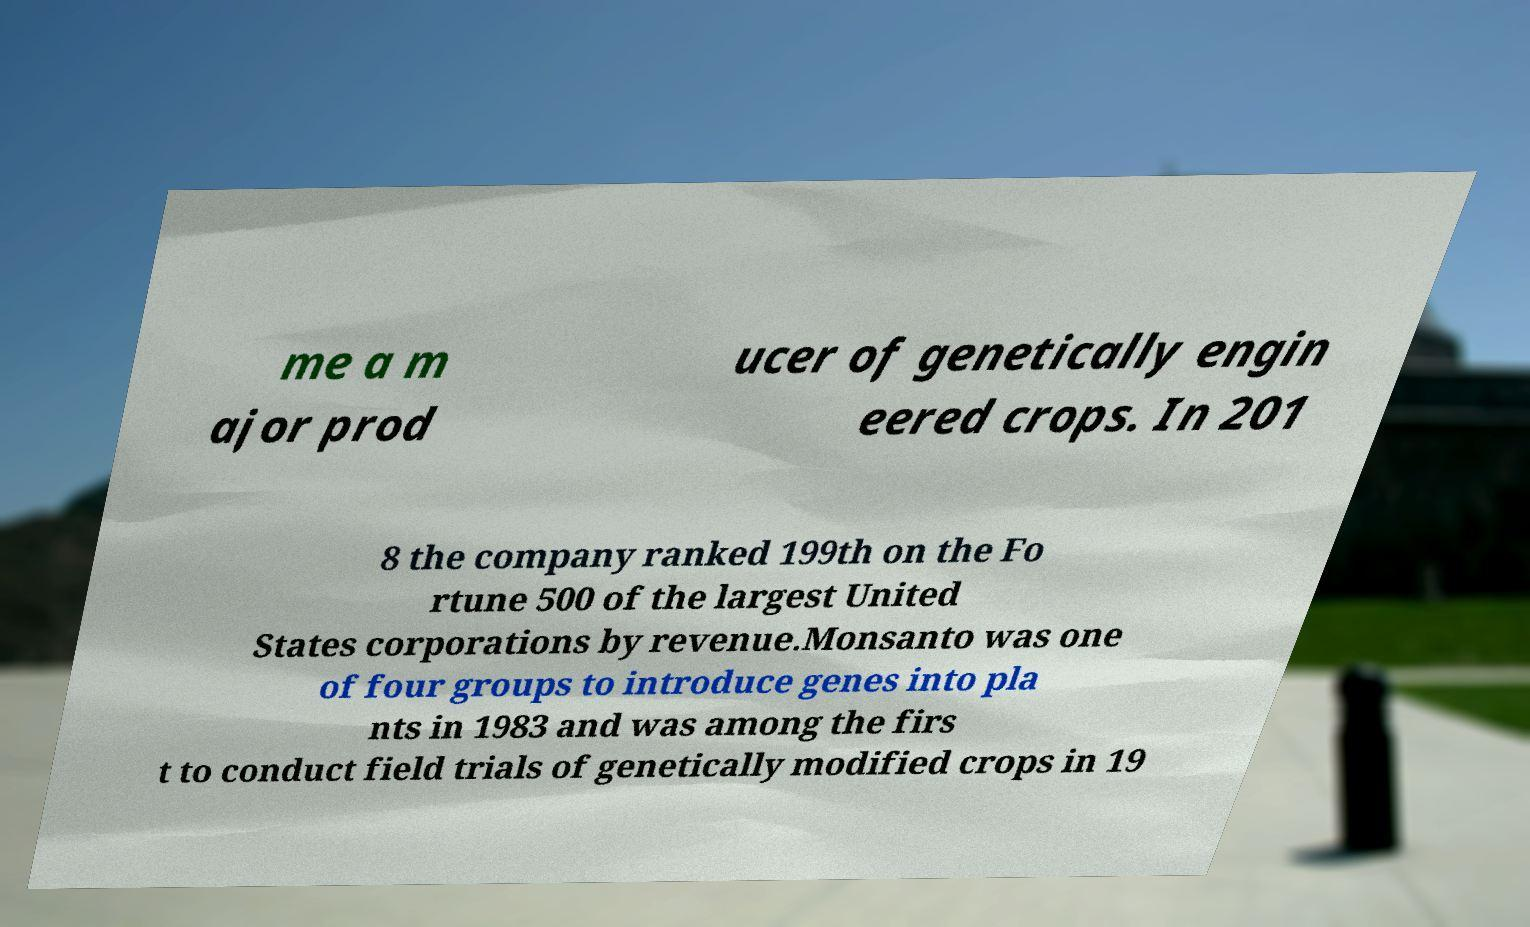Could you assist in decoding the text presented in this image and type it out clearly? me a m ajor prod ucer of genetically engin eered crops. In 201 8 the company ranked 199th on the Fo rtune 500 of the largest United States corporations by revenue.Monsanto was one of four groups to introduce genes into pla nts in 1983 and was among the firs t to conduct field trials of genetically modified crops in 19 